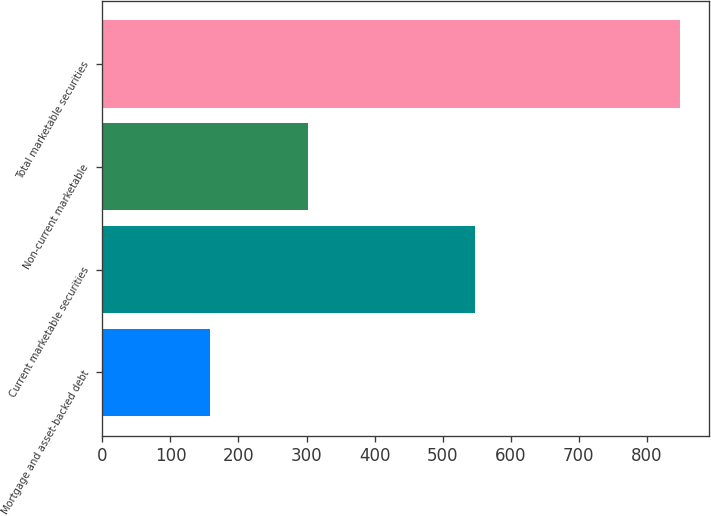<chart> <loc_0><loc_0><loc_500><loc_500><bar_chart><fcel>Mortgage and asset-backed debt<fcel>Current marketable securities<fcel>Non-current marketable<fcel>Total marketable securities<nl><fcel>158<fcel>547<fcel>302<fcel>849<nl></chart> 